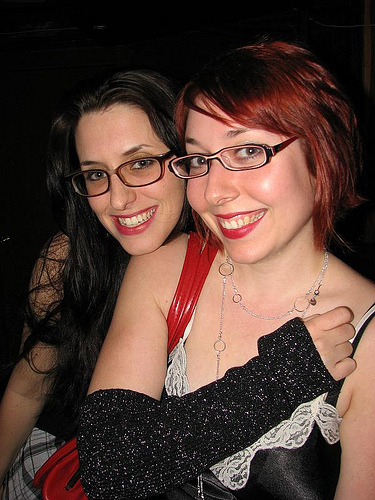<image>
Is there a necklace on the woman? No. The necklace is not positioned on the woman. They may be near each other, but the necklace is not supported by or resting on top of the woman. Is the red hair to the right of the black hair? No. The red hair is not to the right of the black hair. The horizontal positioning shows a different relationship. 